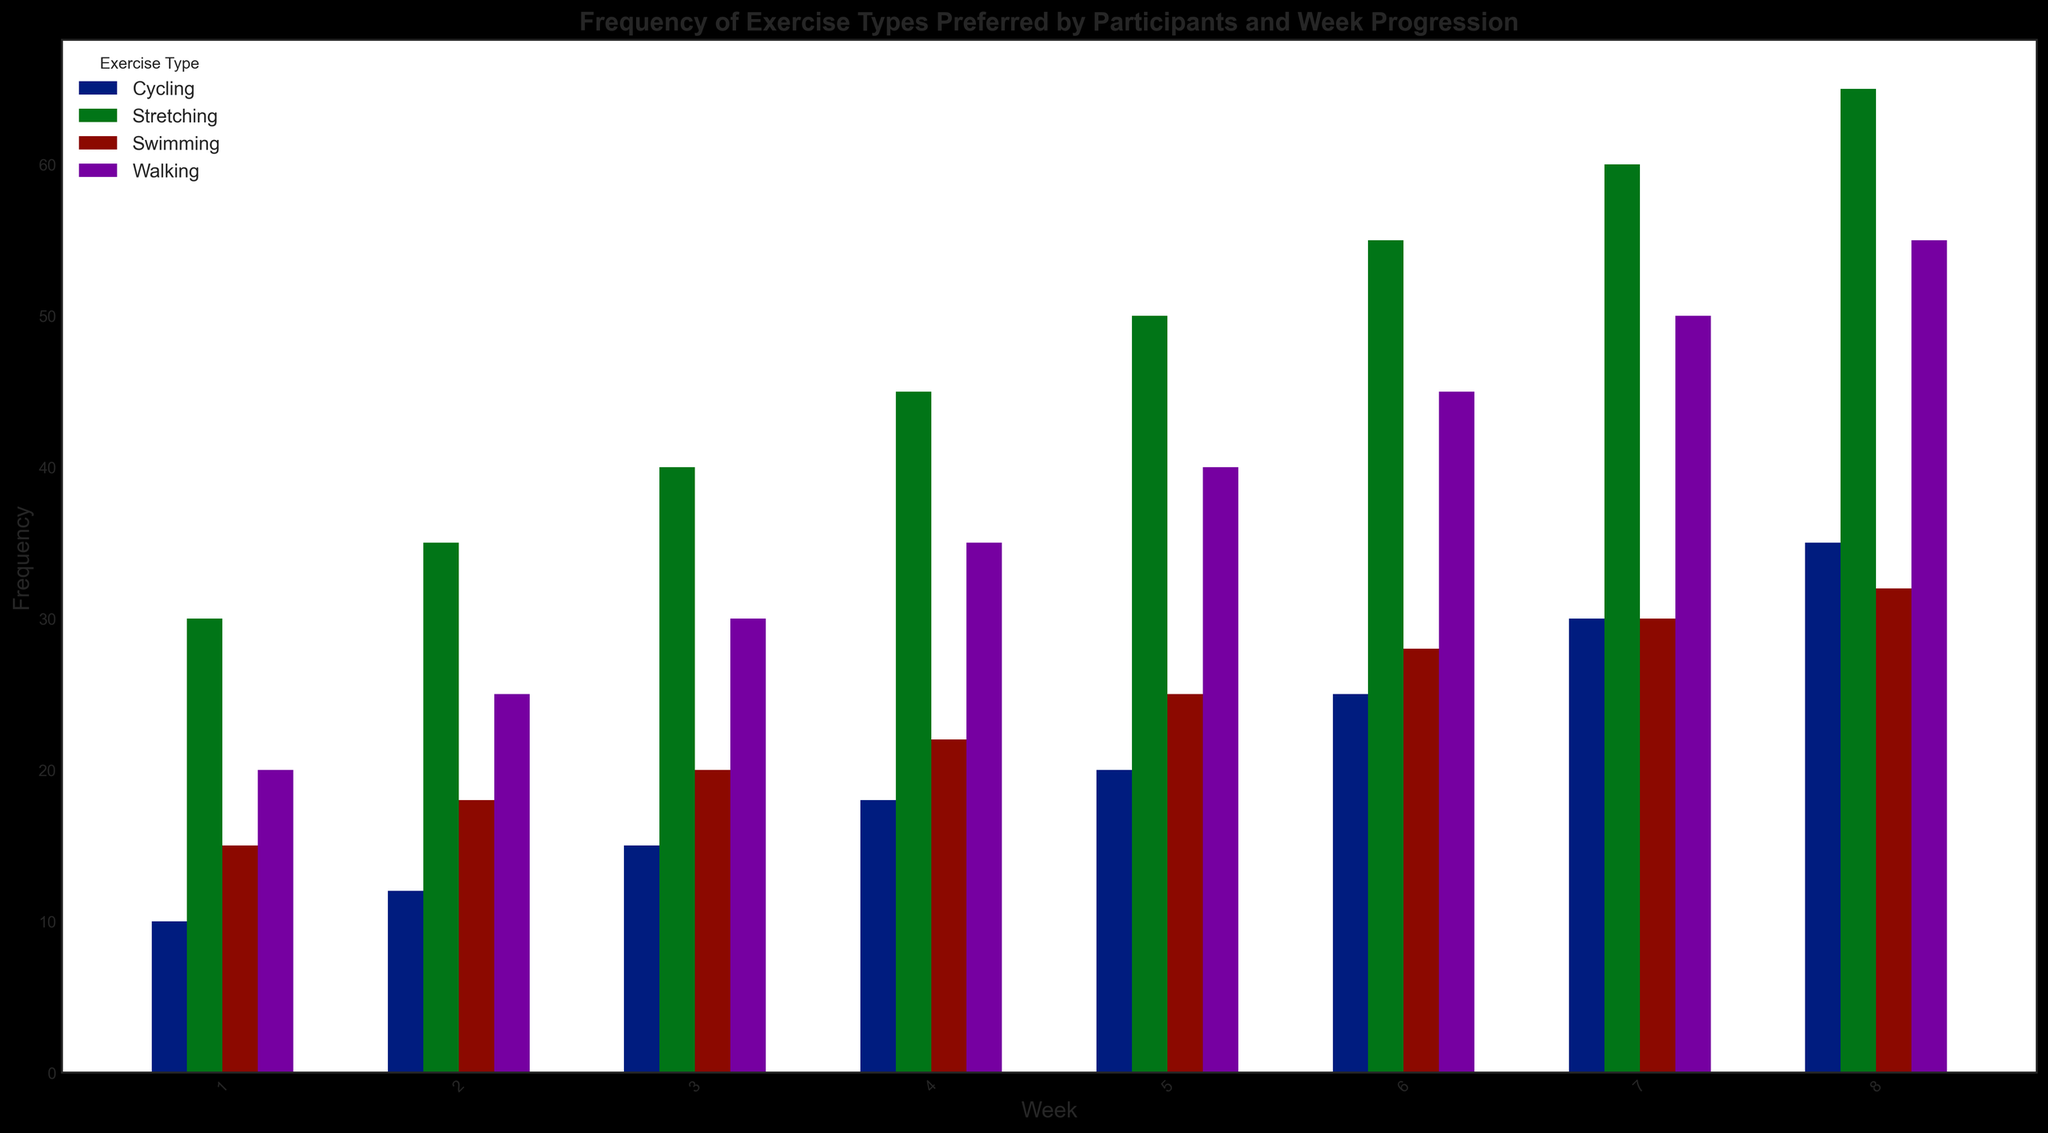What exercise type had the highest frequency in Week 1? By examining Week 1 on the X-axis and comparing the heights of the bars, the tallest bar corresponds to Stretching with a frequency of 30.
Answer: Stretching How did the frequency of Walking change from Week 5 to Week 6? By looking at the bars for Walking between Weeks 5 and 6, the height increases from 40 to 45, indicating an increase of 5.
Answer: Increased by 5 Which exercise type consistently showed an increase in frequency each week? By tracing each set of bars through the weeks, all exercise types (Walking, Swimming, Cycling, and Stretching) show a consistent increase in frequency every week.
Answer: All exercise types What is the combined frequency of Swimming and Cycling in Week 7? By summing the heights of the bars for Swimming (30) and Cycling (30) in Week 7, the combined frequency is 30 + 30 = 60.
Answer: 60 Between Walking and Stretching, which showed a higher rate of increase from Week 1 to Week 8? Calculate the difference in frequency from Week 1 to Week 8 for both: Walking (55-20=35), Stretching (65-30=35). Both increased by the same amount.
Answer: Both increased by 35 What is the average frequency of Swimming across all eight weeks? Sum the frequencies of Swimming for all weeks (15+18+20+22+25+28+30+32) and divide by the number of weeks (8): (15+18+20+22+25+28+30+32)/8 = 23.75.
Answer: 23.75 Which week had the highest total frequency of all exercise types combined? Sum the frequencies of all exercise types for each week and compare: Week 8 has the highest combined total (55+32+35+65) = 187.
Answer: Week 8 By what percentage did the frequency of Cycling increase from Week 1 to Week 8? Calculate the initial and final values, subtract to find the increase, then divide by the Week 1 value and multiply by 100: ((35 - 10) / 10) * 100 = 250%.
Answer: 250% Which exercise type had the smallest increase in frequency from Week 1 to Week 8? Calculate the difference for each exercise type: Walking (35), Swimming (17), Cycling (25), Stretching (35). Swimming had the smallest increase.
Answer: Swimming 